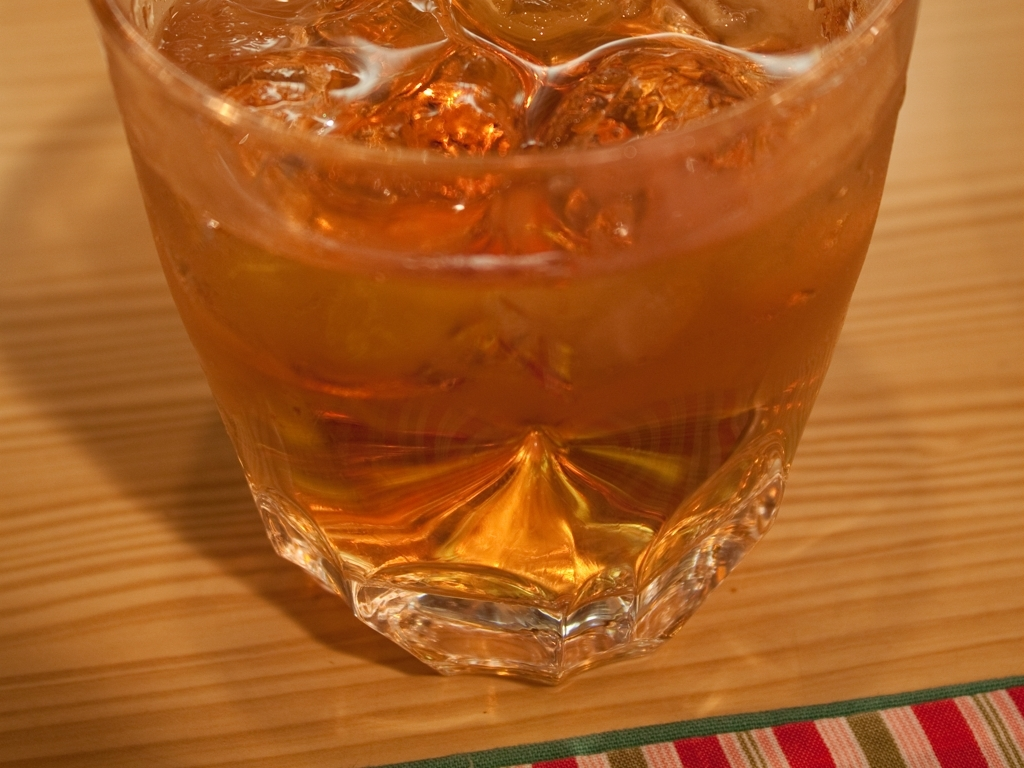Is the glass cup clear? Yes, the glass cup is clear. Its transparency allows you to see the liquid inside, which appears to be iced tea or a similarly colored beverage. The clarity of the glass is evidenced by the visible details such as the ice cubes, the reflections on the surface of the liquid, and the texture of the wooden table beneath. 